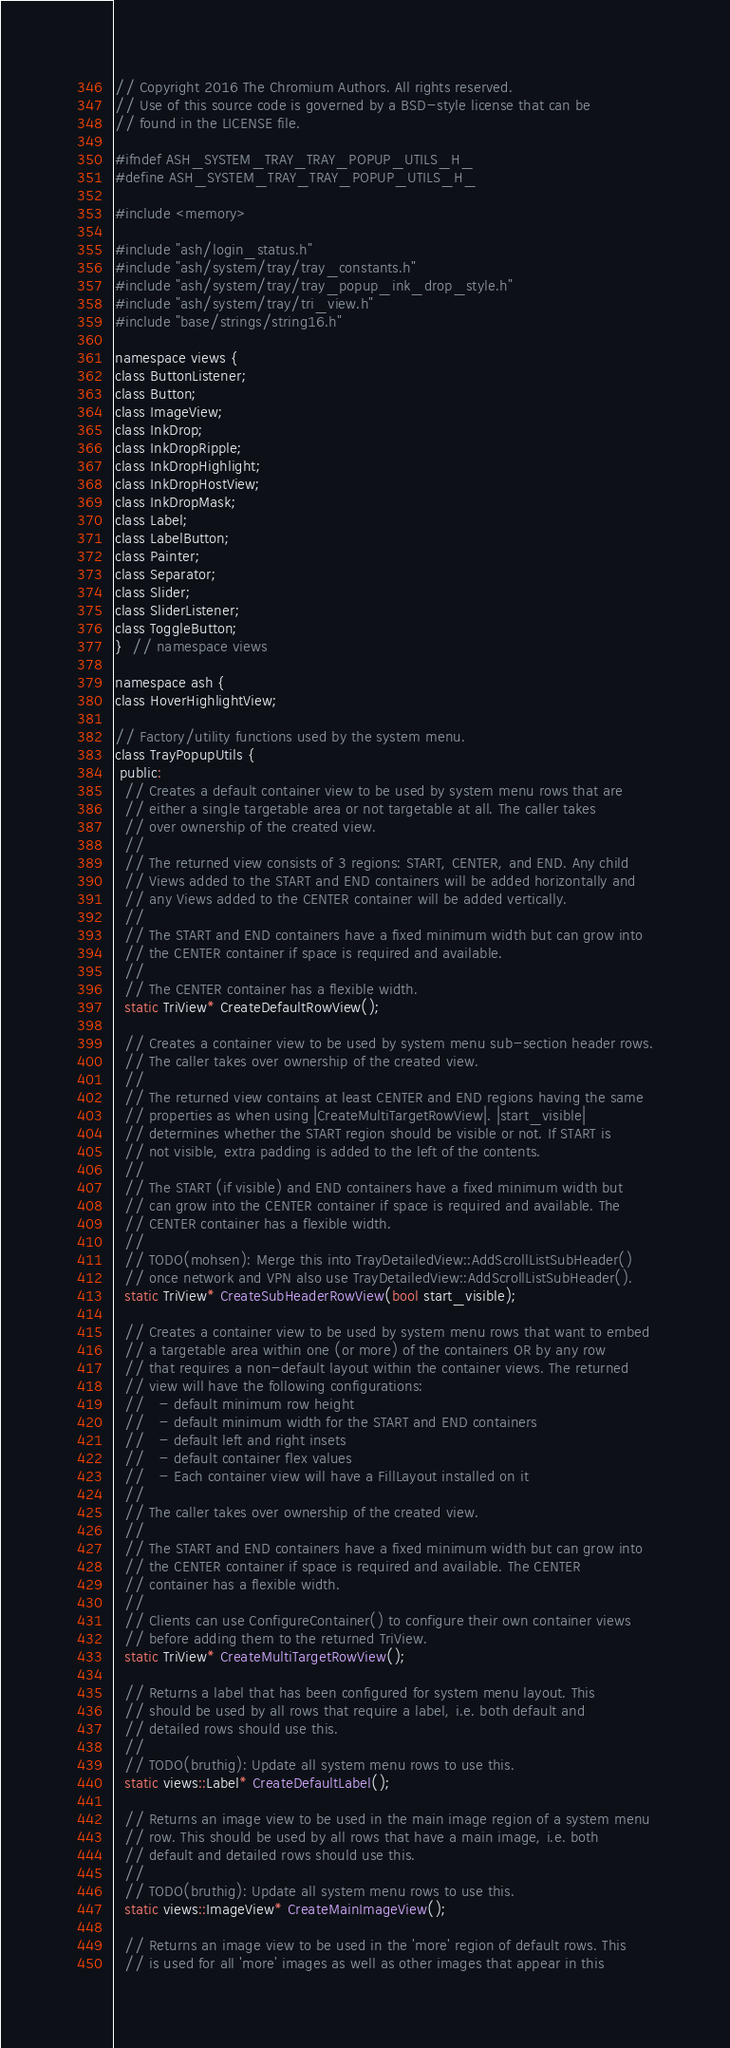Convert code to text. <code><loc_0><loc_0><loc_500><loc_500><_C_>// Copyright 2016 The Chromium Authors. All rights reserved.
// Use of this source code is governed by a BSD-style license that can be
// found in the LICENSE file.

#ifndef ASH_SYSTEM_TRAY_TRAY_POPUP_UTILS_H_
#define ASH_SYSTEM_TRAY_TRAY_POPUP_UTILS_H_

#include <memory>

#include "ash/login_status.h"
#include "ash/system/tray/tray_constants.h"
#include "ash/system/tray/tray_popup_ink_drop_style.h"
#include "ash/system/tray/tri_view.h"
#include "base/strings/string16.h"

namespace views {
class ButtonListener;
class Button;
class ImageView;
class InkDrop;
class InkDropRipple;
class InkDropHighlight;
class InkDropHostView;
class InkDropMask;
class Label;
class LabelButton;
class Painter;
class Separator;
class Slider;
class SliderListener;
class ToggleButton;
}  // namespace views

namespace ash {
class HoverHighlightView;

// Factory/utility functions used by the system menu.
class TrayPopupUtils {
 public:
  // Creates a default container view to be used by system menu rows that are
  // either a single targetable area or not targetable at all. The caller takes
  // over ownership of the created view.
  //
  // The returned view consists of 3 regions: START, CENTER, and END. Any child
  // Views added to the START and END containers will be added horizontally and
  // any Views added to the CENTER container will be added vertically.
  //
  // The START and END containers have a fixed minimum width but can grow into
  // the CENTER container if space is required and available.
  //
  // The CENTER container has a flexible width.
  static TriView* CreateDefaultRowView();

  // Creates a container view to be used by system menu sub-section header rows.
  // The caller takes over ownership of the created view.
  //
  // The returned view contains at least CENTER and END regions having the same
  // properties as when using |CreateMultiTargetRowView|. |start_visible|
  // determines whether the START region should be visible or not. If START is
  // not visible, extra padding is added to the left of the contents.
  //
  // The START (if visible) and END containers have a fixed minimum width but
  // can grow into the CENTER container if space is required and available. The
  // CENTER container has a flexible width.
  //
  // TODO(mohsen): Merge this into TrayDetailedView::AddScrollListSubHeader()
  // once network and VPN also use TrayDetailedView::AddScrollListSubHeader().
  static TriView* CreateSubHeaderRowView(bool start_visible);

  // Creates a container view to be used by system menu rows that want to embed
  // a targetable area within one (or more) of the containers OR by any row
  // that requires a non-default layout within the container views. The returned
  // view will have the following configurations:
  //   - default minimum row height
  //   - default minimum width for the START and END containers
  //   - default left and right insets
  //   - default container flex values
  //   - Each container view will have a FillLayout installed on it
  //
  // The caller takes over ownership of the created view.
  //
  // The START and END containers have a fixed minimum width but can grow into
  // the CENTER container if space is required and available. The CENTER
  // container has a flexible width.
  //
  // Clients can use ConfigureContainer() to configure their own container views
  // before adding them to the returned TriView.
  static TriView* CreateMultiTargetRowView();

  // Returns a label that has been configured for system menu layout. This
  // should be used by all rows that require a label, i.e. both default and
  // detailed rows should use this.
  //
  // TODO(bruthig): Update all system menu rows to use this.
  static views::Label* CreateDefaultLabel();

  // Returns an image view to be used in the main image region of a system menu
  // row. This should be used by all rows that have a main image, i.e. both
  // default and detailed rows should use this.
  //
  // TODO(bruthig): Update all system menu rows to use this.
  static views::ImageView* CreateMainImageView();

  // Returns an image view to be used in the 'more' region of default rows. This
  // is used for all 'more' images as well as other images that appear in this</code> 